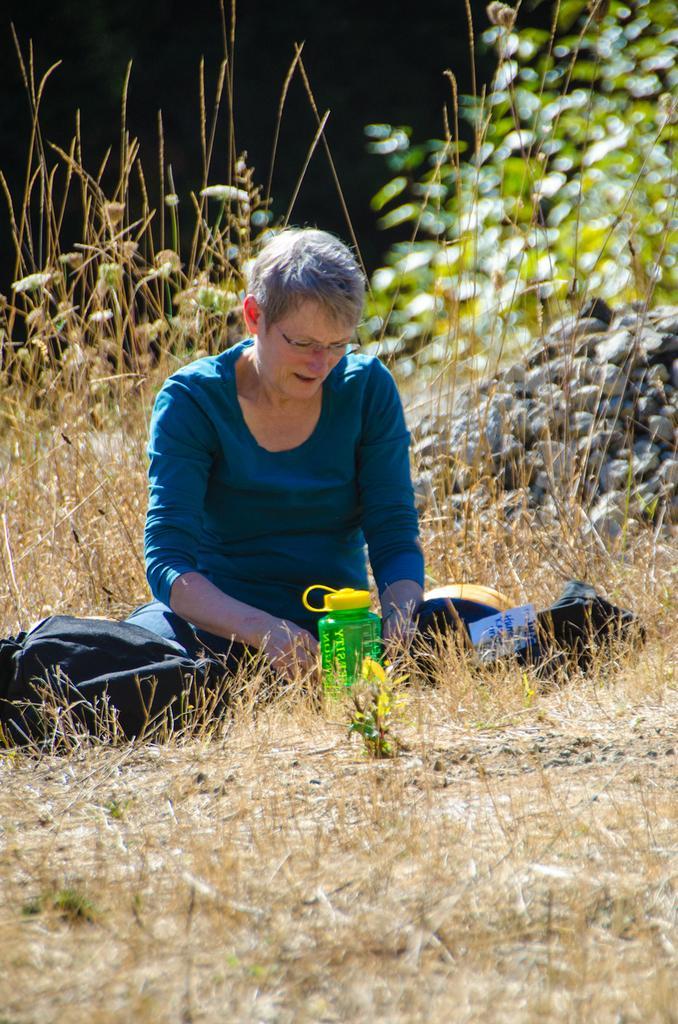Describe this image in one or two sentences. In this picture there is a woman sitting on the grass with blue shirt and behind her there are some plants and stones. 